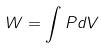Convert formula to latex. <formula><loc_0><loc_0><loc_500><loc_500>W = \int P d V</formula> 